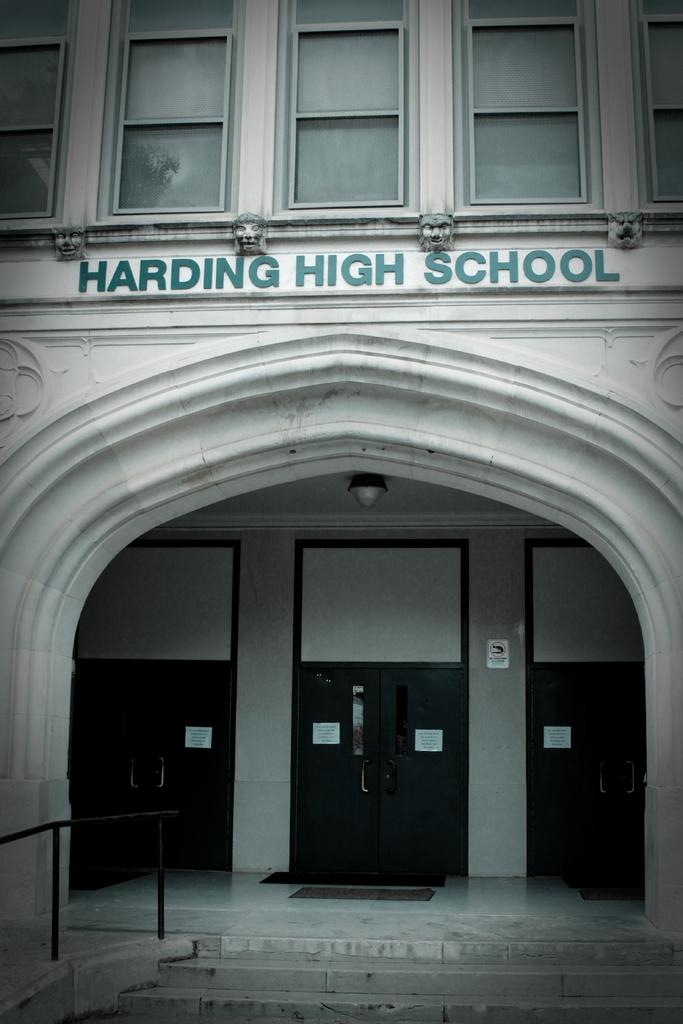What type of structure is in the image? There is a building in the image. Where is the building located in relation to the viewer? The building is in front of the viewer. What can be seen at the bottom of the image? There is railing and steps visible at the bottom of the image. How many words are written in the middle of the image? There are three words written in the middle of the image. What type of dog can be seen practicing religion in the image? There is no dog or religious practice depicted in the image. What sound does the whistle make in the image? There is no whistle present in the image. 